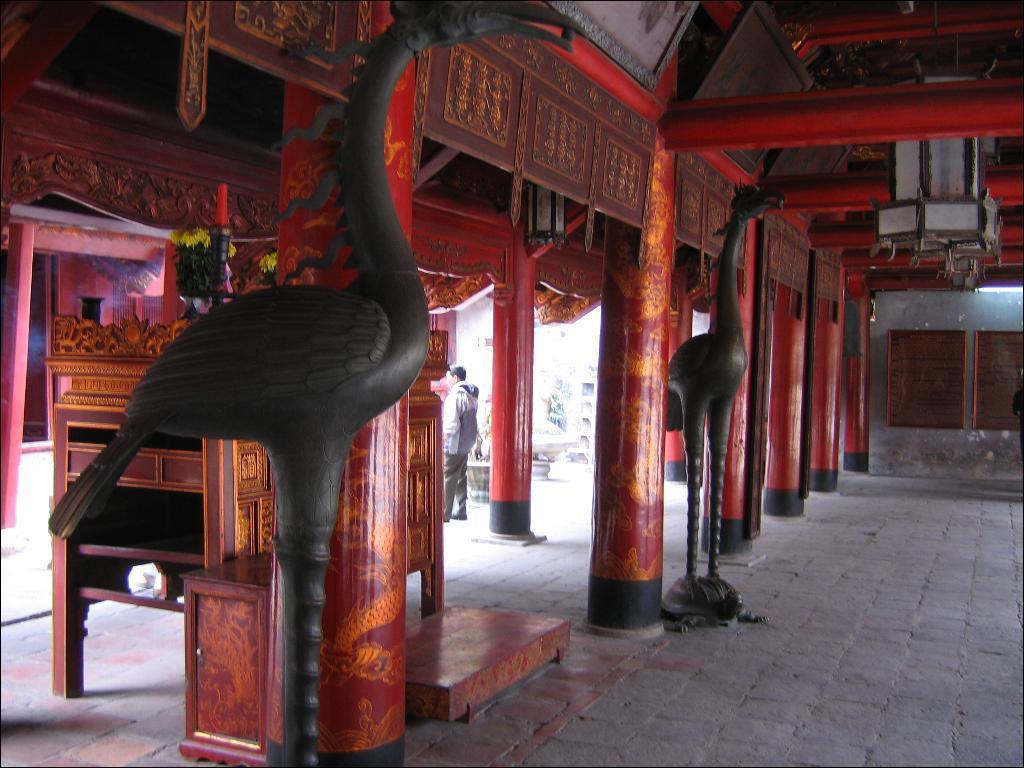Please provide a concise description of this image. In this picture we can see statues, wall, pillars, frames, table are there. In the center of the image a man is standing. At the top of the image we can see a roof is there. On the right side of the image light is there. At the bottom of the image a floor is there. 